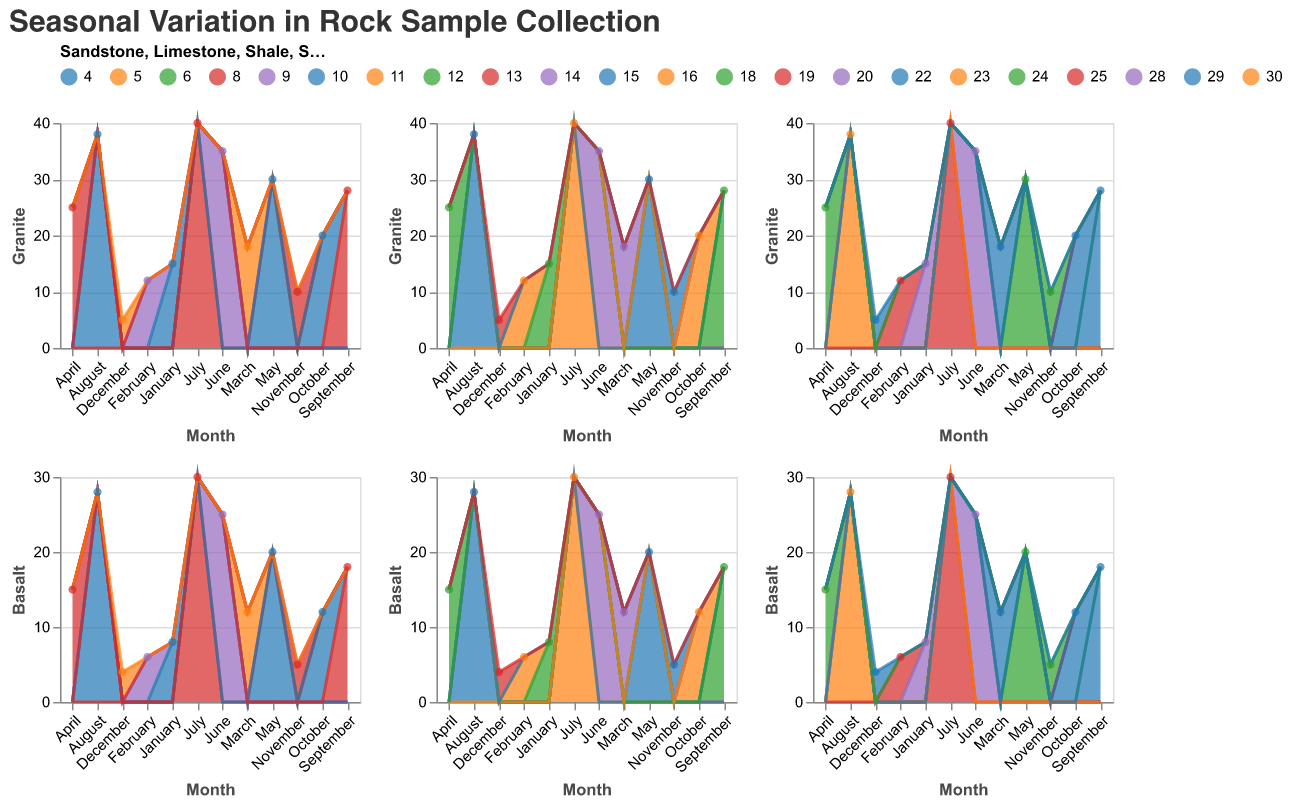What is the title of the figure? The title of the figure is located at the top and is clearly marked in a larger font size compared to the rest of the text in the figure.
Answer: Seasonal Variation in Rock Sample Collection Which month has the highest collection of Granite samples? By observing the Granite area chart, the peak value for Granite can be identified as the tallest point on the chart for a specific month.
Answer: July What is the Limestone sample count for December? By cross-referencing the December marker on the x-axis with the y-axis value in the Limestone area chart, the count can be determined.
Answer: 8 Which rock type has the lowest collection in November? By comparing the values of all the rock types in November, we can identify the lowest value on the y-axis across all subplots.
Answer: Basalt How does the collection trend for Granite change throughout the year? By following the Granite area chart from January to December, the trend (increasing or decreasing) over the months can be observed.
Answer: Increases until July, then decreases Compare July's Shale collection to August's Shale collection. Which month had a higher count? By locating the Shale subplot and comparing the y-axis values for July and August, the month with the higher value can be identified.
Answer: July What is the difference in Basalt samples collected between June and December? By identifying the Basalt counts for June and December and subtracting the December count from the June count, the difference can be calculated.
Answer: 21 Which month shows the lowest collection of Sandstone samples? By finding the minimum point on the Sandstone area chart across all months, the lowest month can be identified.
Answer: December What is the combined total of Limestone samples collected in March, April, and May? By summing the y-axis values of Limestone for March, April, and May, the total collection for these months can be calculated.
Answer: 54 In which month does the Shale collection first exceed 20 samples? By identifying the month where the Shale area chart crosses the y-axis value of 20 for the first time, the month can be determined.
Answer: June 